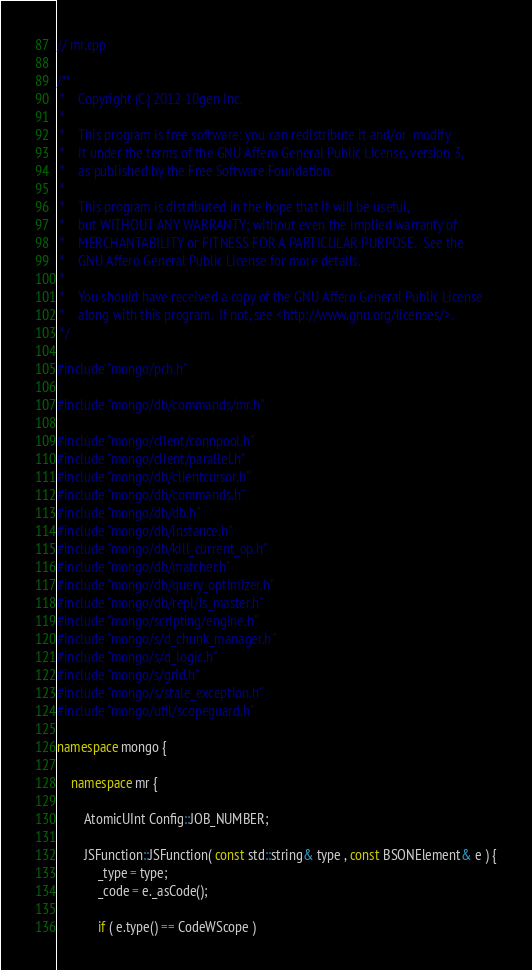<code> <loc_0><loc_0><loc_500><loc_500><_C++_>// mr.cpp

/**
 *    Copyright (C) 2012 10gen Inc.
 *
 *    This program is free software: you can redistribute it and/or  modify
 *    it under the terms of the GNU Affero General Public License, version 3,
 *    as published by the Free Software Foundation.
 *
 *    This program is distributed in the hope that it will be useful,
 *    but WITHOUT ANY WARRANTY; without even the implied warranty of
 *    MERCHANTABILITY or FITNESS FOR A PARTICULAR PURPOSE.  See the
 *    GNU Affero General Public License for more details.
 *
 *    You should have received a copy of the GNU Affero General Public License
 *    along with this program.  If not, see <http://www.gnu.org/licenses/>.
 */

#include "mongo/pch.h"

#include "mongo/db/commands/mr.h"

#include "mongo/client/connpool.h"
#include "mongo/client/parallel.h"
#include "mongo/db/clientcursor.h"
#include "mongo/db/commands.h"
#include "mongo/db/db.h"
#include "mongo/db/instance.h"
#include "mongo/db/kill_current_op.h"
#include "mongo/db/matcher.h"
#include "mongo/db/query_optimizer.h"
#include "mongo/db/repl/is_master.h"
#include "mongo/scripting/engine.h"
#include "mongo/s/d_chunk_manager.h"
#include "mongo/s/d_logic.h"
#include "mongo/s/grid.h"
#include "mongo/s/stale_exception.h"
#include "mongo/util/scopeguard.h"

namespace mongo {

    namespace mr {

        AtomicUInt Config::JOB_NUMBER;

        JSFunction::JSFunction( const std::string& type , const BSONElement& e ) {
            _type = type;
            _code = e._asCode();

            if ( e.type() == CodeWScope )</code> 